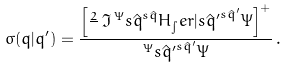<formula> <loc_0><loc_0><loc_500><loc_500>\sigma ( q | q ^ { \prime } ) = \frac { \left [ \frac { 2 } { } \, \Im \, ^ { \Psi } { s \hat { q } } ^ { s \hat { q } } { H _ { \int } e r | s \hat { q } ^ { \prime } } ^ { s \hat { q } ^ { \prime } } { \Psi } \right ] ^ { + } } { ^ { \Psi } { s \hat { q } ^ { \prime } } ^ { s \hat { q } ^ { \prime } } { \Psi } } \, .</formula> 